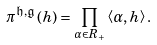Convert formula to latex. <formula><loc_0><loc_0><loc_500><loc_500>\pi ^ { \mathfrak h , \mathfrak g } \left ( h \right ) = \prod _ { \alpha \in R _ { + } } \left \langle \alpha , h \right \rangle .</formula> 